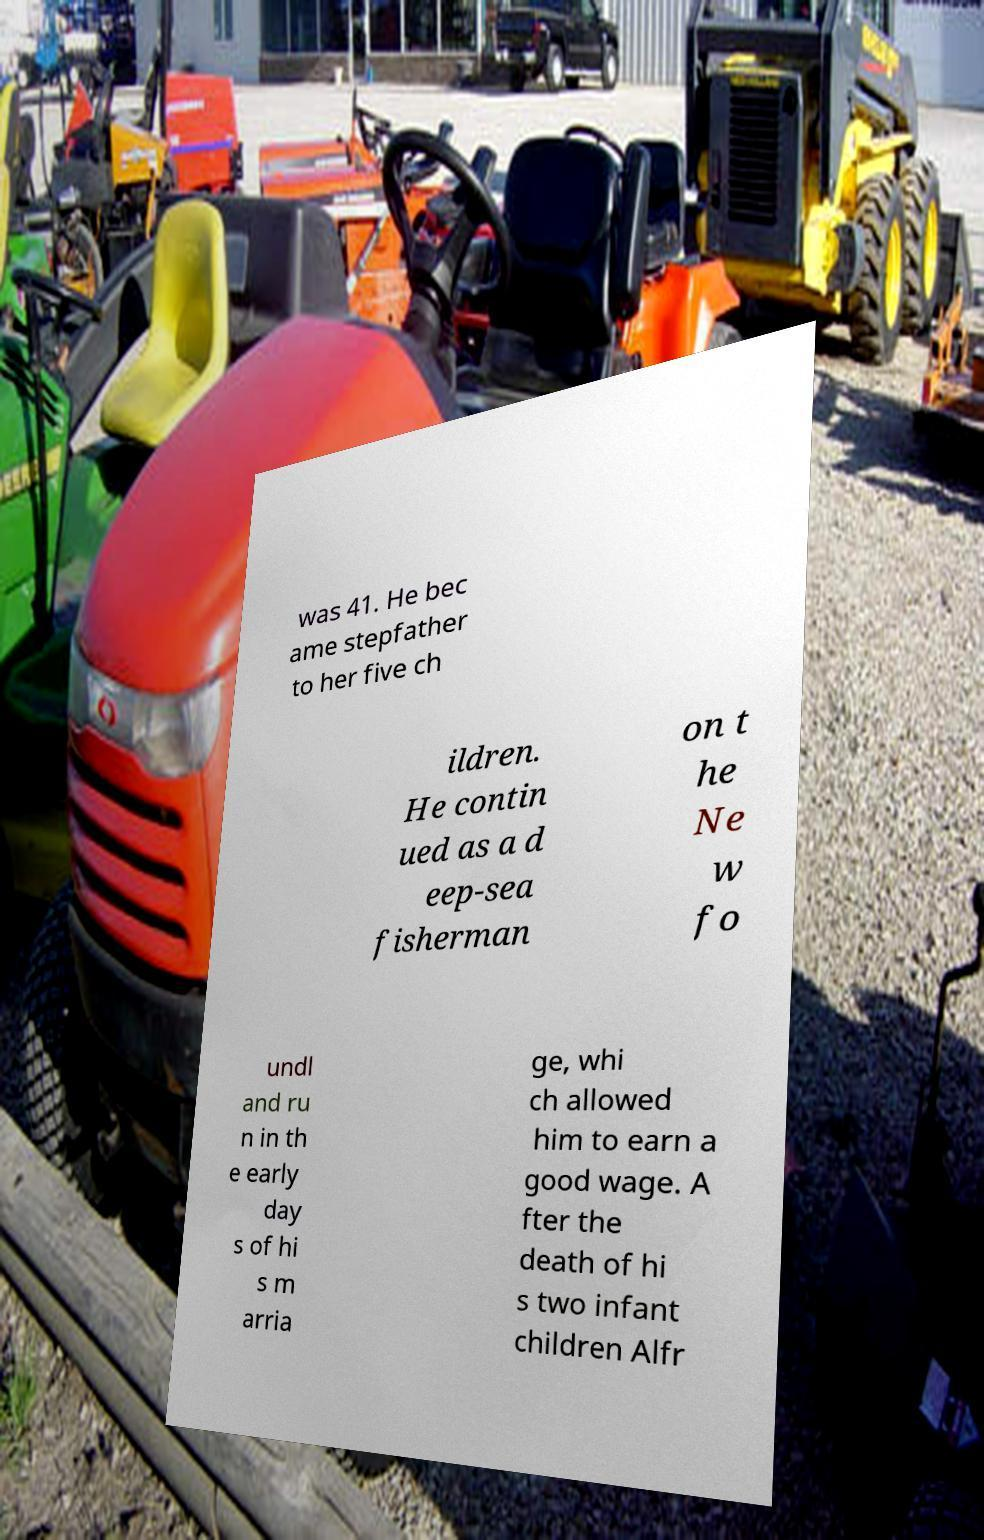Could you assist in decoding the text presented in this image and type it out clearly? was 41. He bec ame stepfather to her five ch ildren. He contin ued as a d eep-sea fisherman on t he Ne w fo undl and ru n in th e early day s of hi s m arria ge, whi ch allowed him to earn a good wage. A fter the death of hi s two infant children Alfr 